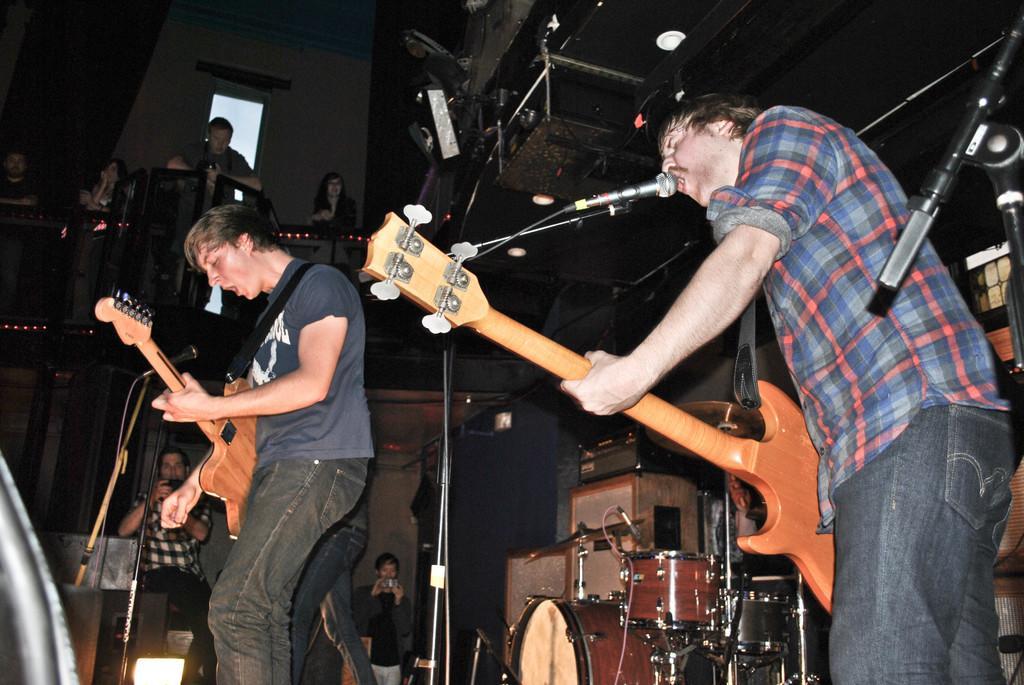Describe this image in one or two sentences. These two persons are singing and playing guitar in-front of mic. On top these are audience. Far these two persons are holding mobile. These are musical instruments. Beside this musical instruments there are boxes. 